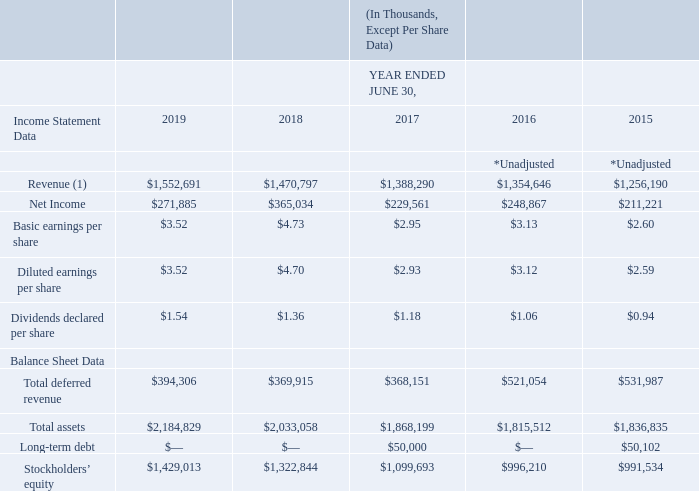SELECTED FINANCIAL DATA
The following data should be read in conjunction with the consolidated financial statements and accompanying notes included elsewhere in the Annual Report on Form 10-K. Fiscal 2018 and 2017 have been recast to reflect the Company’s retrospective adoption of Accounting Standards Update (“ASU”) 2014-09, Revenue from Contracts with Customers, and related amendments, collectively referred to as Accounting Standards Codification (“ASC”) 606. Fiscal 2016 and 2015 were not recast. Net income for fiscal 2018 and 2019 has been impacted by the reduced U.S. corporate tax rate enacted by the Tax Cuts and Jobs Act (“TCJA”) of 2017, and fiscal 2018 net income contains the related adjustment for the re-measurement of deferred taxes. Acquisitions have affected revenue and net income in fiscal 2019 as well as the historical periods presented.
(1) Revenue includes license sales, support and service revenues, and hardware sales, less returns and allowances.
Which financial years' information is shown in the table? 2015, 2016, 2017, 2018, 2019. What is the revenue for all 5 fiscal years, in chronological order?
Answer scale should be: thousand. $1,256,190, $1,354,646, $1,388,290, $1,470,797, $1,552,691. What is the net income for all 5 fiscal years, in chronological order?
Answer scale should be: thousand. $211,221, $248,867, $229,561, $365,034, $271,885. What is the average revenue for 2018 and 2019?
Answer scale should be: thousand. ($1,552,691+$1,470,797)/2
Answer: 1511744. What is the average revenue for 2017 and 2018?
Answer scale should be: thousand. ($1,470,797+$1,388,290)/2
Answer: 1429543.5. What is the change in the average revenue between 2017-2018 and 2018-2019?
Answer scale should be: thousand. [($1,552,691+$1,470,797)/2] - [($1,470,797+$1,388,290)/2]
Answer: 82200.5. 